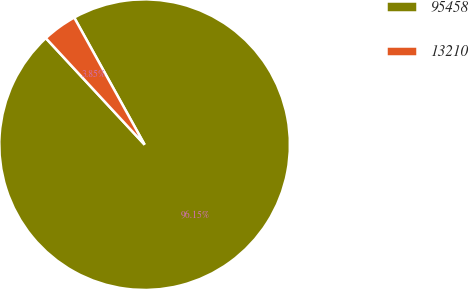Convert chart. <chart><loc_0><loc_0><loc_500><loc_500><pie_chart><fcel>95458<fcel>13210<nl><fcel>96.15%<fcel>3.85%<nl></chart> 